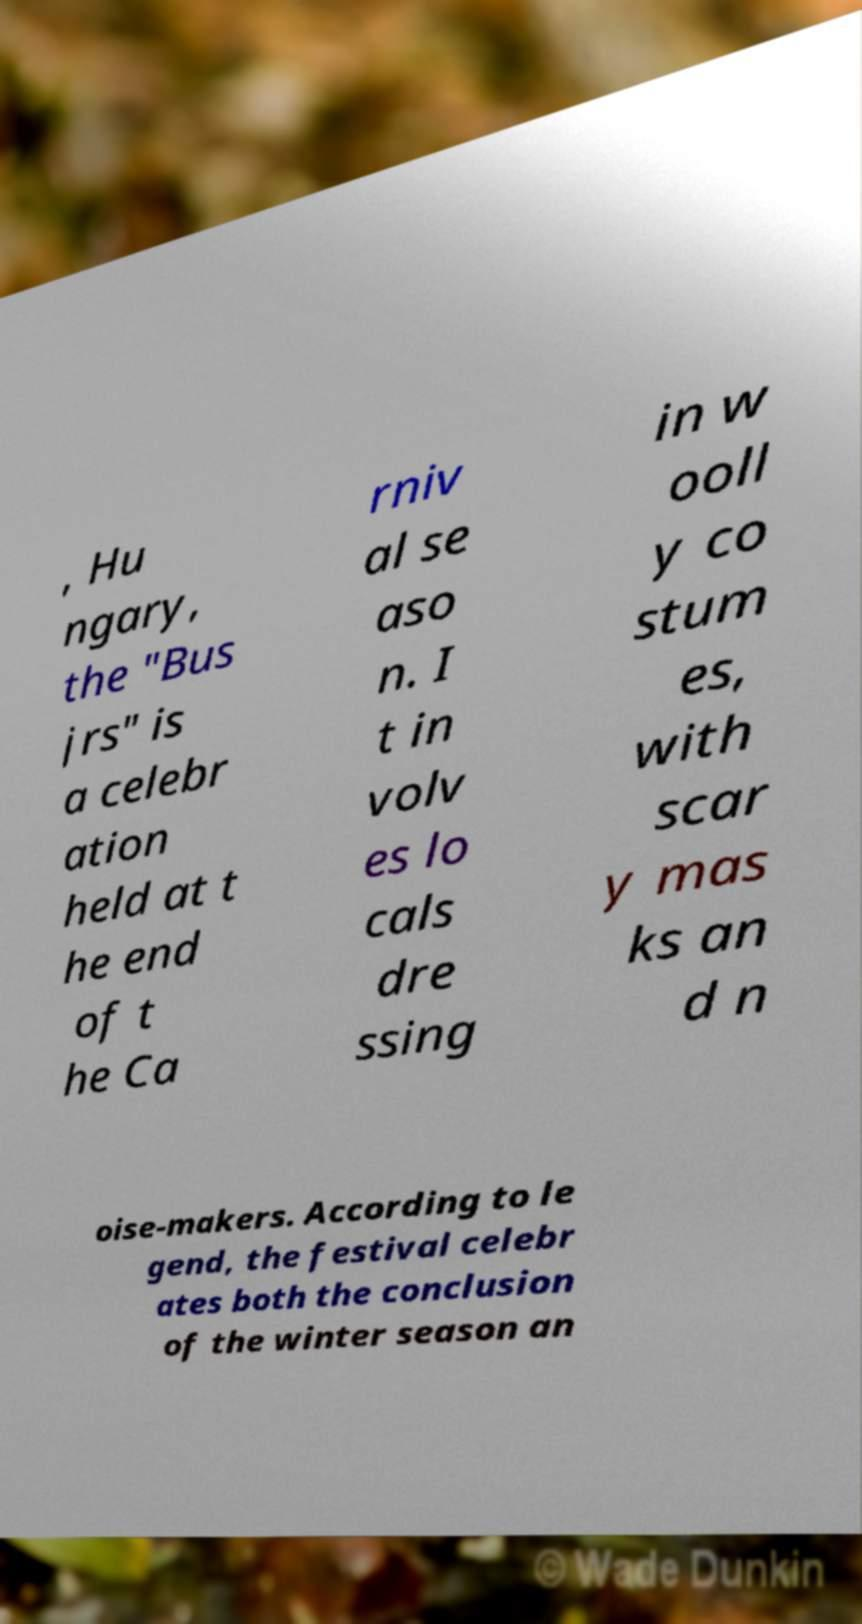Can you accurately transcribe the text from the provided image for me? , Hu ngary, the "Bus jrs" is a celebr ation held at t he end of t he Ca rniv al se aso n. I t in volv es lo cals dre ssing in w ooll y co stum es, with scar y mas ks an d n oise-makers. According to le gend, the festival celebr ates both the conclusion of the winter season an 